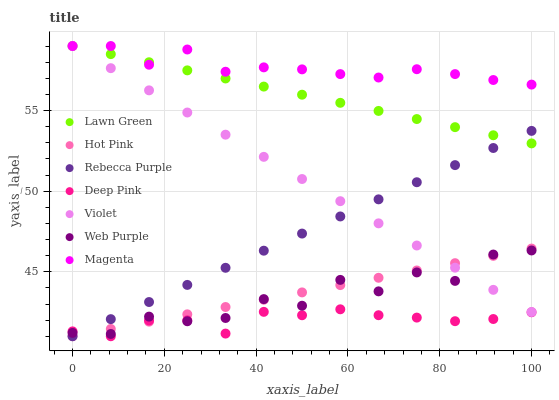Does Deep Pink have the minimum area under the curve?
Answer yes or no. Yes. Does Magenta have the maximum area under the curve?
Answer yes or no. Yes. Does Hot Pink have the minimum area under the curve?
Answer yes or no. No. Does Hot Pink have the maximum area under the curve?
Answer yes or no. No. Is Hot Pink the smoothest?
Answer yes or no. Yes. Is Web Purple the roughest?
Answer yes or no. Yes. Is Deep Pink the smoothest?
Answer yes or no. No. Is Deep Pink the roughest?
Answer yes or no. No. Does Deep Pink have the lowest value?
Answer yes or no. Yes. Does Web Purple have the lowest value?
Answer yes or no. No. Does Magenta have the highest value?
Answer yes or no. Yes. Does Hot Pink have the highest value?
Answer yes or no. No. Is Hot Pink less than Magenta?
Answer yes or no. Yes. Is Magenta greater than Hot Pink?
Answer yes or no. Yes. Does Web Purple intersect Violet?
Answer yes or no. Yes. Is Web Purple less than Violet?
Answer yes or no. No. Is Web Purple greater than Violet?
Answer yes or no. No. Does Hot Pink intersect Magenta?
Answer yes or no. No. 